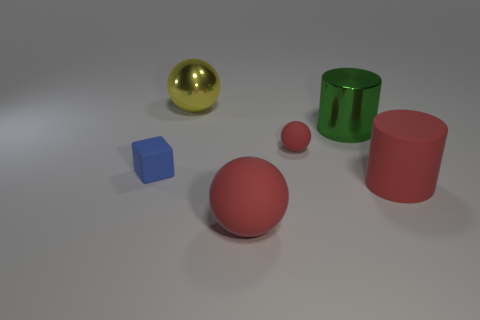Are the large ball in front of the tiny blue object and the small object on the left side of the yellow object made of the same material?
Your answer should be compact. Yes. What material is the big cylinder that is the same color as the big rubber sphere?
Provide a short and direct response. Rubber. What is the shape of the rubber thing that is behind the large red rubber ball and to the left of the small red matte ball?
Your response must be concise. Cube. What is the material of the sphere that is behind the small rubber thing to the right of the tiny blue thing?
Your answer should be very brief. Metal. Is the number of red shiny things greater than the number of large matte cylinders?
Offer a terse response. No. Do the big metallic cylinder and the rubber cube have the same color?
Offer a terse response. No. What is the material of the green cylinder that is the same size as the red rubber cylinder?
Keep it short and to the point. Metal. Do the yellow thing and the small ball have the same material?
Make the answer very short. No. What number of big green cylinders have the same material as the blue block?
Give a very brief answer. 0. How many things are red matte cylinders in front of the rubber cube or cylinders in front of the blue rubber object?
Provide a short and direct response. 1. 